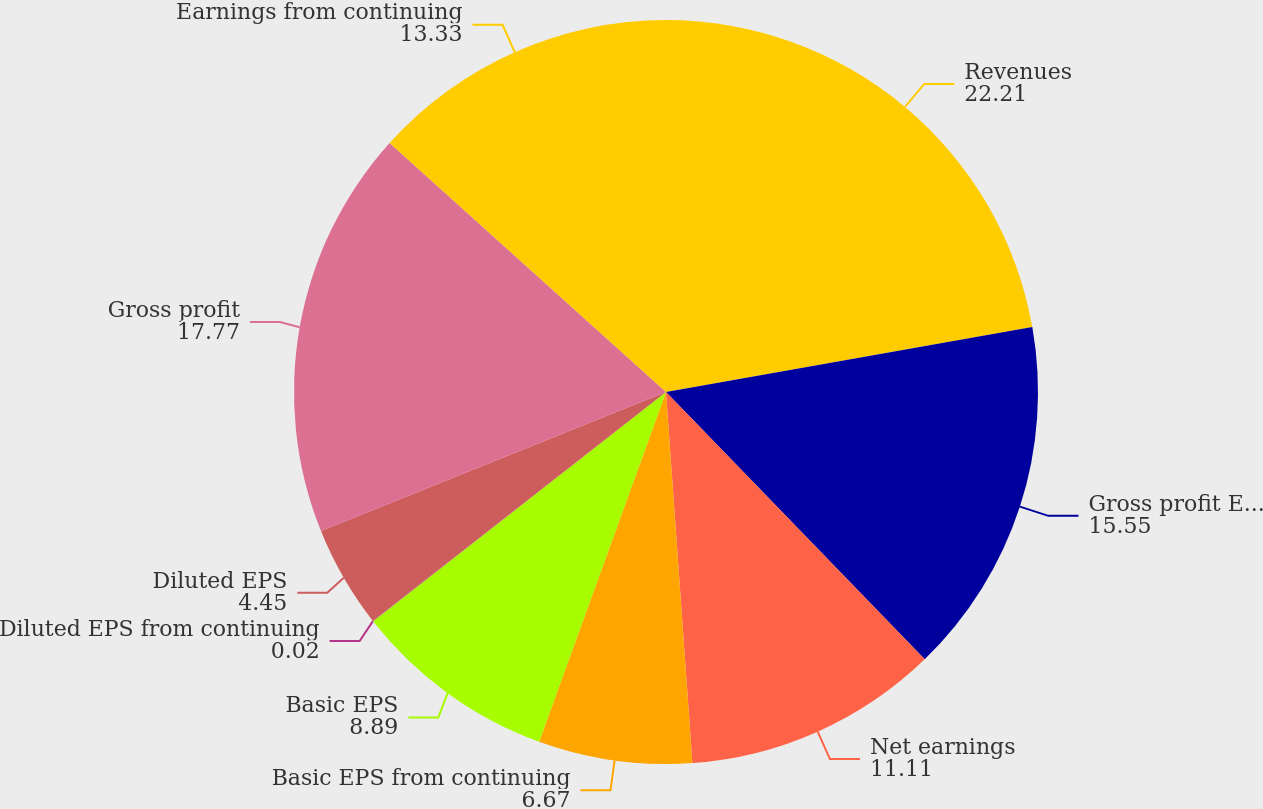Convert chart. <chart><loc_0><loc_0><loc_500><loc_500><pie_chart><fcel>Revenues<fcel>Gross profit Earnings from<fcel>Net earnings<fcel>Basic EPS from continuing<fcel>Basic EPS<fcel>Diluted EPS from continuing<fcel>Diluted EPS<fcel>Gross profit<fcel>Earnings from continuing<nl><fcel>22.21%<fcel>15.55%<fcel>11.11%<fcel>6.67%<fcel>8.89%<fcel>0.02%<fcel>4.45%<fcel>17.77%<fcel>13.33%<nl></chart> 